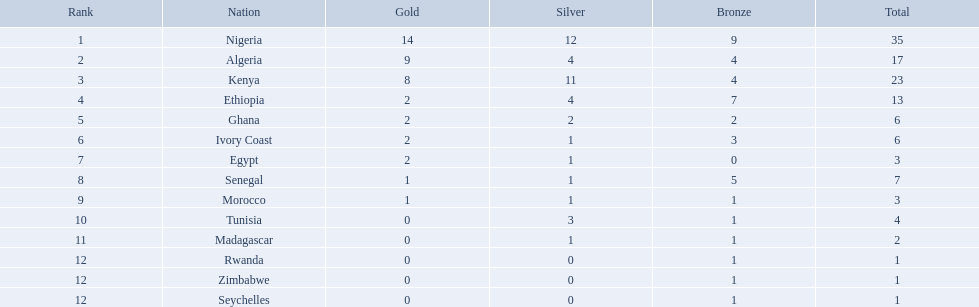What are all the nations? Nigeria, Algeria, Kenya, Ethiopia, Ghana, Ivory Coast, Egypt, Senegal, Morocco, Tunisia, Madagascar, Rwanda, Zimbabwe, Seychelles. How many bronze medals did they win? 9, 4, 4, 7, 2, 3, 0, 5, 1, 1, 1, 1, 1, 1. And which nation did not win one? Egypt. Which nations were involved in the 1989 african championships in athletics? Nigeria, Algeria, Kenya, Ethiopia, Ghana, Ivory Coast, Egypt, Senegal, Morocco, Tunisia, Madagascar, Rwanda, Zimbabwe, Seychelles. Which nations received bronze medals? Nigeria, Algeria, Kenya, Ethiopia, Ghana, Ivory Coast, Senegal, Morocco, Tunisia, Madagascar, Rwanda, Zimbabwe, Seychelles. Which nation did not manage to get a bronze medal? Egypt. What countries took part in the 1989 african championships in athletics? Nigeria, Algeria, Kenya, Ethiopia, Ghana, Ivory Coast, Egypt, Senegal, Morocco, Tunisia, Madagascar, Rwanda, Zimbabwe, Seychelles. What countries acquired bronze medals? Nigeria, Algeria, Kenya, Ethiopia, Ghana, Ivory Coast, Senegal, Morocco, Tunisia, Madagascar, Rwanda, Zimbabwe, Seychelles. What country did not achieve a bronze medal? Egypt. What are all the sovereignties? Nigeria, Algeria, Kenya, Ethiopia, Ghana, Ivory Coast, Egypt, Senegal, Morocco, Tunisia, Madagascar, Rwanda, Zimbabwe, Seychelles. How many bronze medals did they acquire? 9, 4, 4, 7, 2, 3, 0, 5, 1, 1, 1, 1, 1, 1. And which sovereignty did not win one? Egypt. Which countries participated in the 1989 african athletics championships? Nigeria, Algeria, Kenya, Ethiopia, Ghana, Ivory Coast, Egypt, Senegal, Morocco, Tunisia, Madagascar, Rwanda, Zimbabwe, Seychelles. Which countries secured bronze medals? Nigeria, Algeria, Kenya, Ethiopia, Ghana, Ivory Coast, Senegal, Morocco, Tunisia, Madagascar, Rwanda, Zimbabwe, Seychelles. Which country failed to obtain a bronze medal? Egypt. Parse the full table. {'header': ['Rank', 'Nation', 'Gold', 'Silver', 'Bronze', 'Total'], 'rows': [['1', 'Nigeria', '14', '12', '9', '35'], ['2', 'Algeria', '9', '4', '4', '17'], ['3', 'Kenya', '8', '11', '4', '23'], ['4', 'Ethiopia', '2', '4', '7', '13'], ['5', 'Ghana', '2', '2', '2', '6'], ['6', 'Ivory Coast', '2', '1', '3', '6'], ['7', 'Egypt', '2', '1', '0', '3'], ['8', 'Senegal', '1', '1', '5', '7'], ['9', 'Morocco', '1', '1', '1', '3'], ['10', 'Tunisia', '0', '3', '1', '4'], ['11', 'Madagascar', '0', '1', '1', '2'], ['12', 'Rwanda', '0', '0', '1', '1'], ['12', 'Zimbabwe', '0', '0', '1', '1'], ['12', 'Seychelles', '0', '0', '1', '1']]} At the 1989 african athletics championships, what nations took part? Nigeria, Algeria, Kenya, Ethiopia, Ghana, Ivory Coast, Egypt, Senegal, Morocco, Tunisia, Madagascar, Rwanda, Zimbabwe, Seychelles. What nations received bronze medals? Nigeria, Algeria, Kenya, Ethiopia, Ghana, Ivory Coast, Senegal, Morocco, Tunisia, Madagascar, Rwanda, Zimbabwe, Seychelles. What nation was unable to achieve a bronze medal? Egypt. What is the complete list of countries? Nigeria, Algeria, Kenya, Ethiopia, Ghana, Ivory Coast, Egypt, Senegal, Morocco, Tunisia, Madagascar, Rwanda, Zimbabwe, Seychelles. How many bronze medals have they each earned? 9, 4, 4, 7, 2, 3, 0, 5, 1, 1, 1, 1, 1, 1. And which country has not won any? Egypt. 